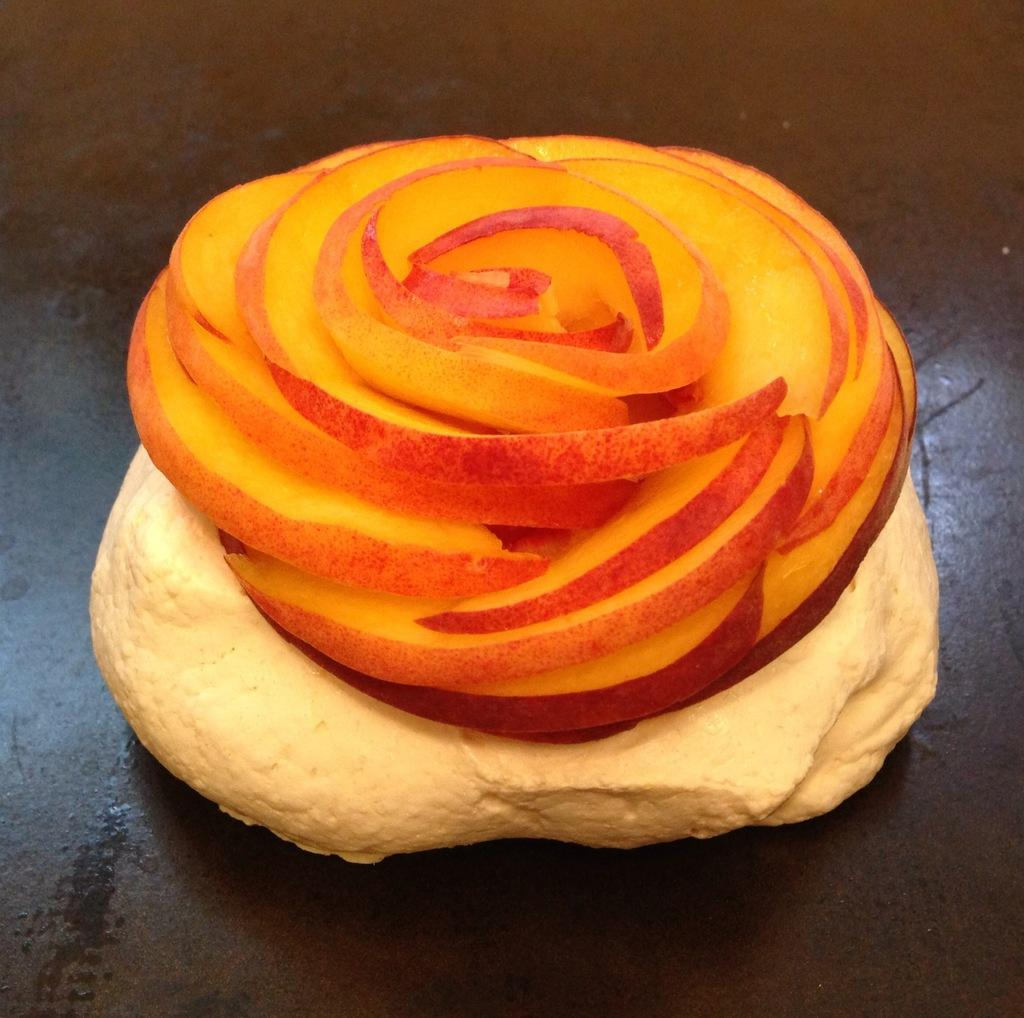What is the main subject of the image? There is a food item in the image. How is the food item positioned in the image? The food item is on a platform. What is unique about the platform's shape? The platform is in the shape of a flower. What type of slope can be seen in the image? There is no slope present in the image. How would you describe the taste of the food item in the image? The taste of the food item cannot be determined from the image alone. 